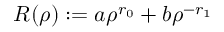Convert formula to latex. <formula><loc_0><loc_0><loc_500><loc_500>R ( \rho ) \colon = a \rho ^ { r _ { 0 } } + b \rho ^ { - r _ { 1 } }</formula> 